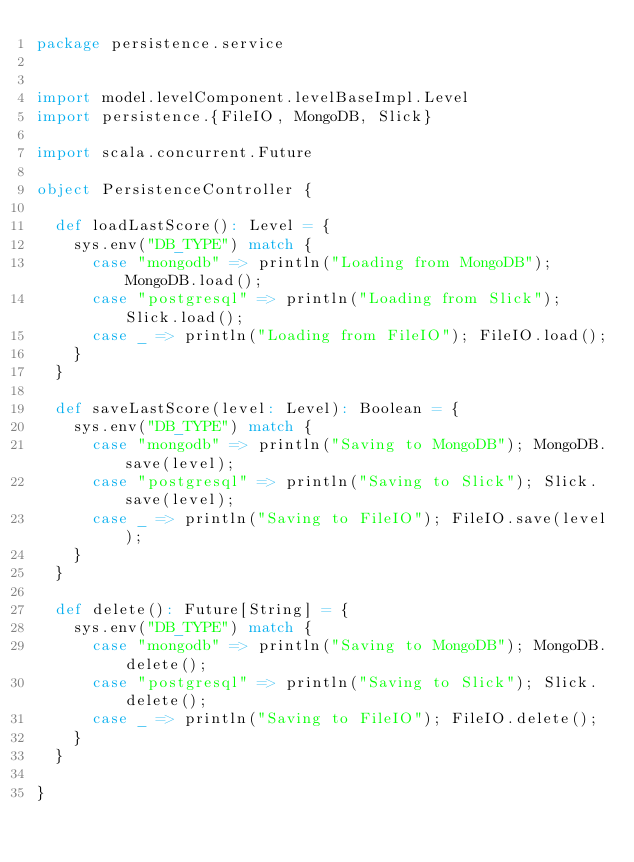<code> <loc_0><loc_0><loc_500><loc_500><_Scala_>package persistence.service


import model.levelComponent.levelBaseImpl.Level
import persistence.{FileIO, MongoDB, Slick}

import scala.concurrent.Future

object PersistenceController {

  def loadLastScore(): Level = {
    sys.env("DB_TYPE") match {
      case "mongodb" => println("Loading from MongoDB"); MongoDB.load();
      case "postgresql" => println("Loading from Slick"); Slick.load();
      case _ => println("Loading from FileIO"); FileIO.load();
    }
  }

  def saveLastScore(level: Level): Boolean = {
    sys.env("DB_TYPE") match {
      case "mongodb" => println("Saving to MongoDB"); MongoDB.save(level);
      case "postgresql" => println("Saving to Slick"); Slick.save(level);
      case _ => println("Saving to FileIO"); FileIO.save(level);
    }
  }

  def delete(): Future[String] = {
    sys.env("DB_TYPE") match {
      case "mongodb" => println("Saving to MongoDB"); MongoDB.delete();
      case "postgresql" => println("Saving to Slick"); Slick.delete();
      case _ => println("Saving to FileIO"); FileIO.delete();
    }
  }

}
</code> 